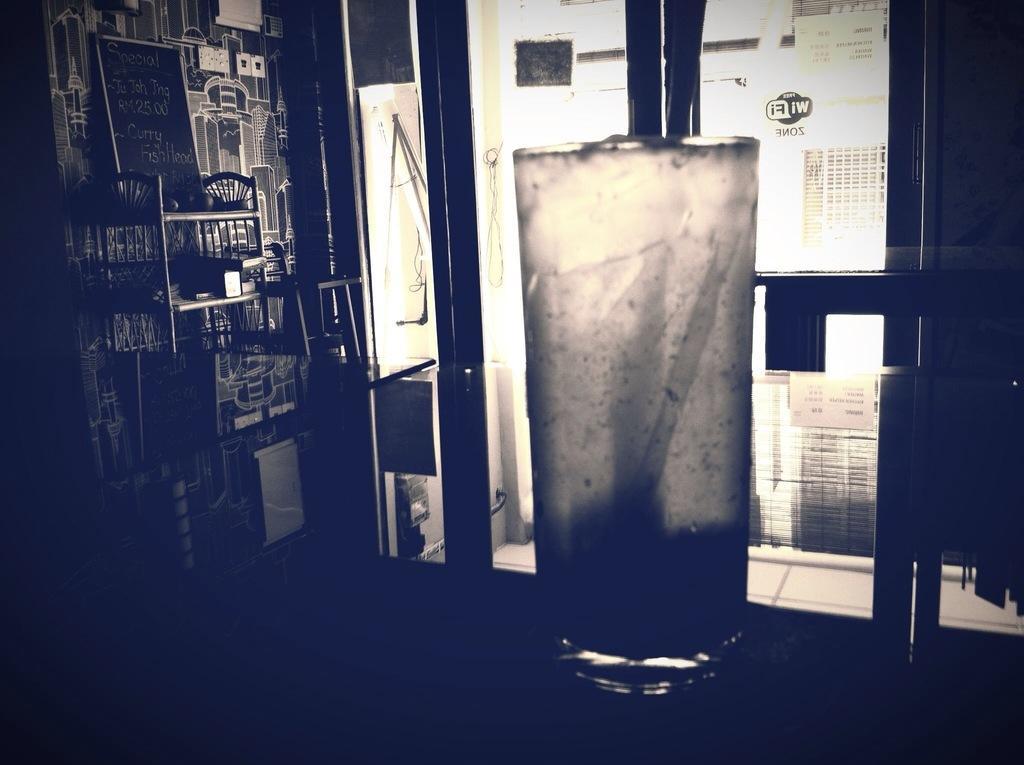Describe this image in one or two sentences. In the center of the image we can see a glass placed on the table. On the left there is a shelf and we can see a board and some things placed in the shelf. In the background there is a door. 